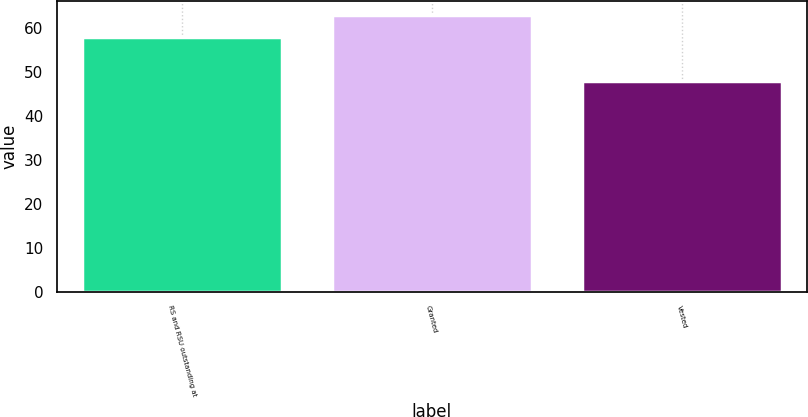Convert chart to OTSL. <chart><loc_0><loc_0><loc_500><loc_500><bar_chart><fcel>RS and RSU outstanding at<fcel>Granted<fcel>Vested<nl><fcel>58<fcel>63<fcel>48<nl></chart> 